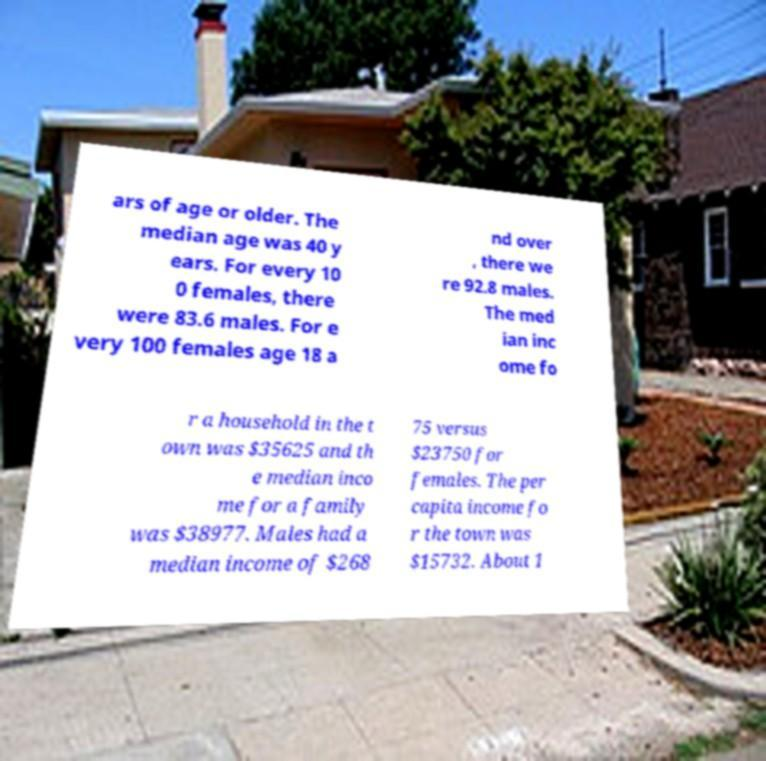Could you assist in decoding the text presented in this image and type it out clearly? ars of age or older. The median age was 40 y ears. For every 10 0 females, there were 83.6 males. For e very 100 females age 18 a nd over , there we re 92.8 males. The med ian inc ome fo r a household in the t own was $35625 and th e median inco me for a family was $38977. Males had a median income of $268 75 versus $23750 for females. The per capita income fo r the town was $15732. About 1 